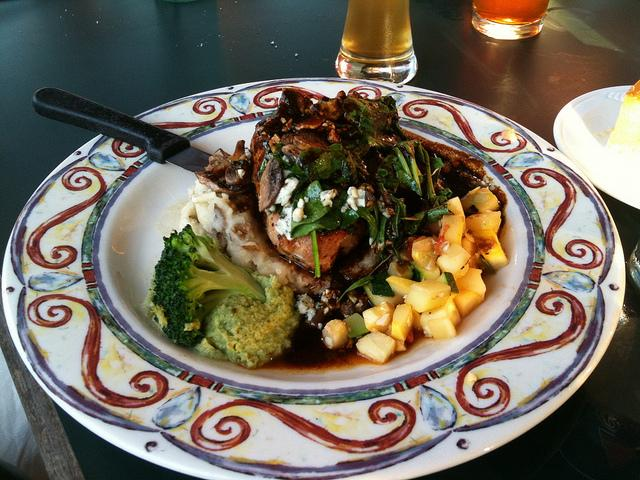What utensil is on the plate?

Choices:
A) spoon
B) chopstick
C) knife
D) fork knife 